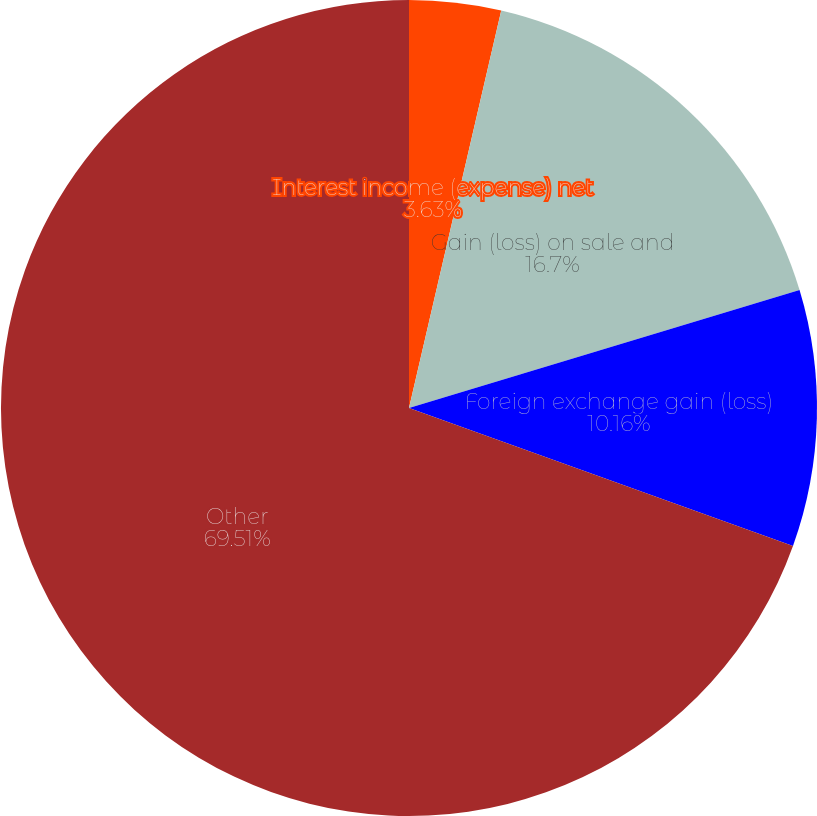<chart> <loc_0><loc_0><loc_500><loc_500><pie_chart><fcel>Interest income (expense) net<fcel>Gain (loss) on sale and<fcel>Foreign exchange gain (loss)<fcel>Other<nl><fcel>3.63%<fcel>16.7%<fcel>10.16%<fcel>69.51%<nl></chart> 